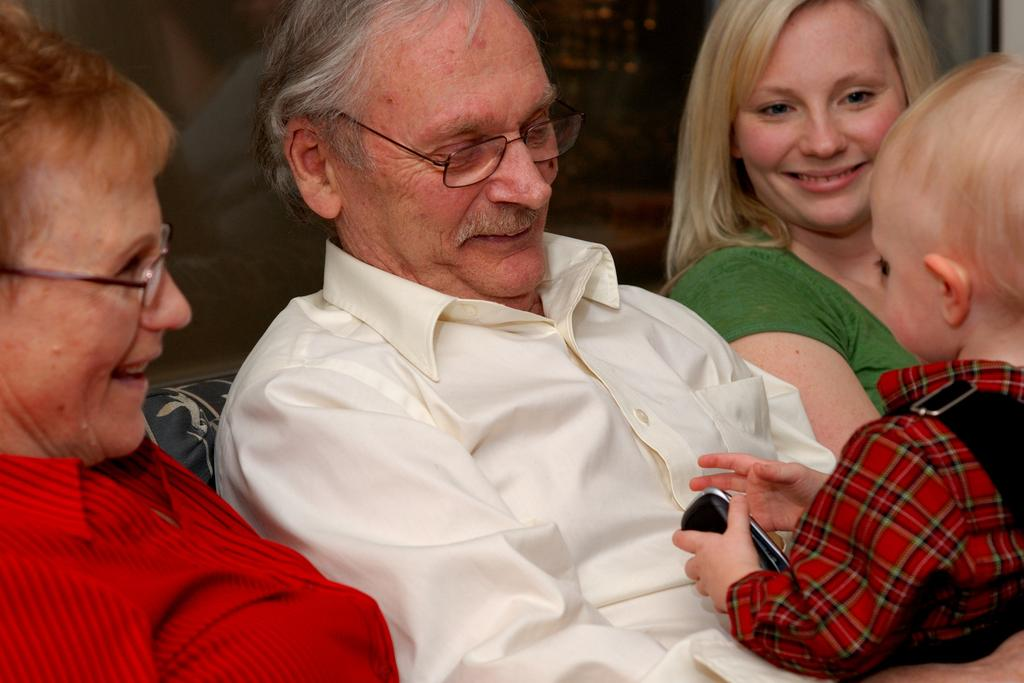How many individuals are present in the image? There are three people in the image. Can you describe the youngest person in the image? There is a kid in the image. What is the kid holding in the image? The kid is holding a phone. What is the profit margin of the truck company mentioned in the image? There is no truck company or mention of profit margins in the image; it features three people, one of whom is a kid holding a phone. 